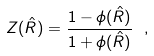Convert formula to latex. <formula><loc_0><loc_0><loc_500><loc_500>Z ( \hat { R } ) = \frac { 1 - \phi ( \hat { R } ) } { 1 + \phi ( \hat { R } ) } \ ,</formula> 